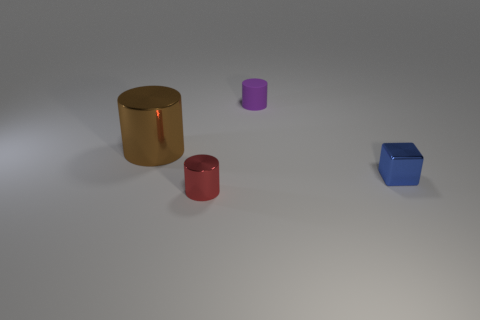Subtract all tiny cylinders. How many cylinders are left? 1 Subtract all red cylinders. How many cylinders are left? 2 Add 3 blue blocks. How many objects exist? 7 Add 2 purple matte cylinders. How many purple matte cylinders are left? 3 Add 1 brown shiny things. How many brown shiny things exist? 2 Subtract 0 blue cylinders. How many objects are left? 4 Subtract all cubes. How many objects are left? 3 Subtract 1 cubes. How many cubes are left? 0 Subtract all green cubes. Subtract all blue cylinders. How many cubes are left? 1 Subtract all cyan spheres. How many gray cylinders are left? 0 